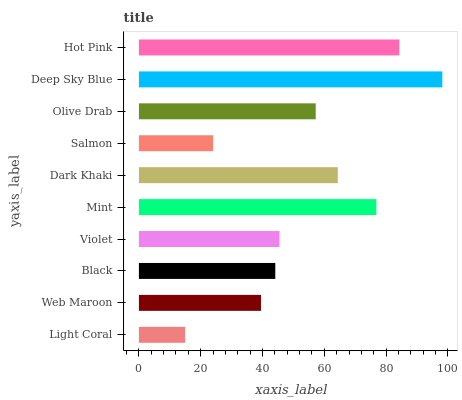Is Light Coral the minimum?
Answer yes or no. Yes. Is Deep Sky Blue the maximum?
Answer yes or no. Yes. Is Web Maroon the minimum?
Answer yes or no. No. Is Web Maroon the maximum?
Answer yes or no. No. Is Web Maroon greater than Light Coral?
Answer yes or no. Yes. Is Light Coral less than Web Maroon?
Answer yes or no. Yes. Is Light Coral greater than Web Maroon?
Answer yes or no. No. Is Web Maroon less than Light Coral?
Answer yes or no. No. Is Olive Drab the high median?
Answer yes or no. Yes. Is Violet the low median?
Answer yes or no. Yes. Is Black the high median?
Answer yes or no. No. Is Web Maroon the low median?
Answer yes or no. No. 